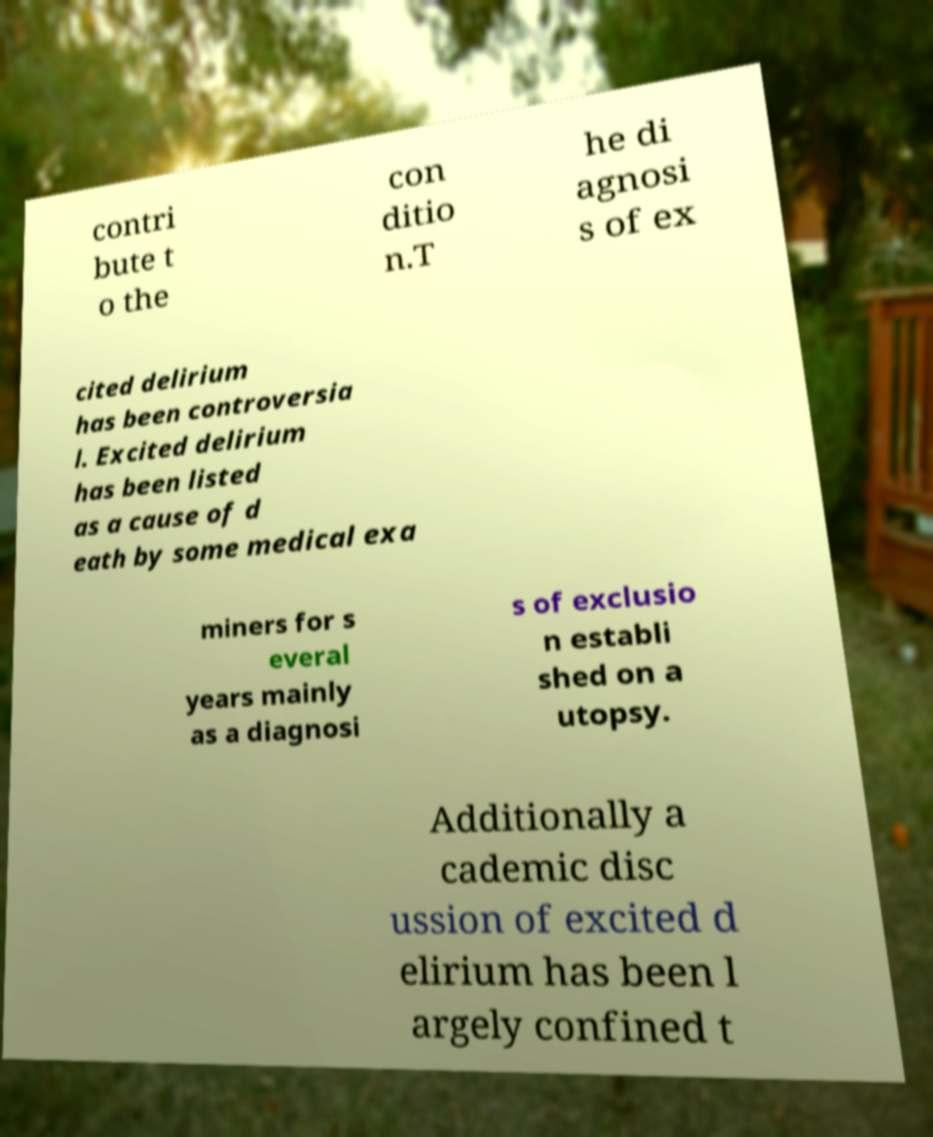Could you extract and type out the text from this image? contri bute t o the con ditio n.T he di agnosi s of ex cited delirium has been controversia l. Excited delirium has been listed as a cause of d eath by some medical exa miners for s everal years mainly as a diagnosi s of exclusio n establi shed on a utopsy. Additionally a cademic disc ussion of excited d elirium has been l argely confined t 